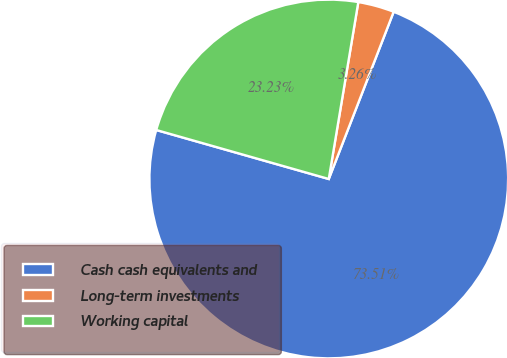<chart> <loc_0><loc_0><loc_500><loc_500><pie_chart><fcel>Cash cash equivalents and<fcel>Long-term investments<fcel>Working capital<nl><fcel>73.51%<fcel>3.26%<fcel>23.23%<nl></chart> 